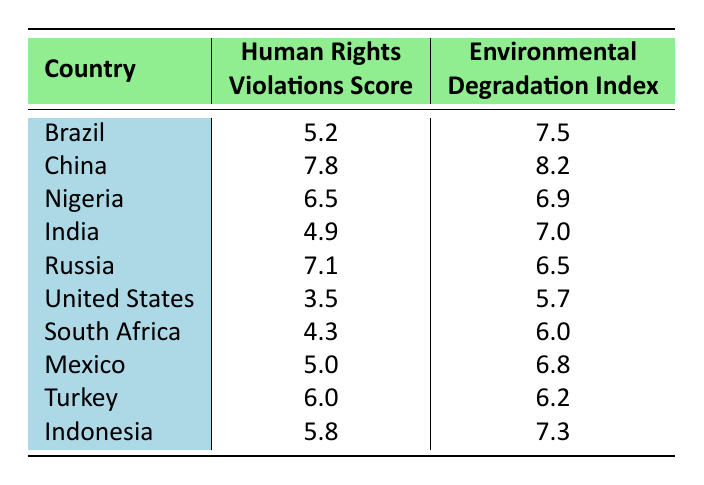What is the Human Rights Violations Score for Brazil? In the table, Brazil has a listed Human Rights Violations Score of 5.2.
Answer: 5.2 Which country has the highest Environmental Degradation Index? By looking at the Environmental Degradation Index values in the table, China has the highest score at 8.2.
Answer: China What is the Environmental Degradation Index for the United States? The table shows that the Environmental Degradation Index score for the United States is 5.7.
Answer: 5.7 What is the difference between the Human Rights Violations Score of China and India? The Human Rights Violations Score for China is 7.8 and for India is 4.9. The difference is 7.8 - 4.9 = 2.9.
Answer: 2.9 Is the Environmental Degradation Index for Nigeria greater than that of Russia? Nigeria has an Environmental Degradation Index of 6.9 while Russia's is 6.5. Since 6.9 is greater than 6.5, the statement is true.
Answer: Yes Which country has a lower Human Rights Violations Score: Turkey or Mexico? Turkey has a score of 6.0 and Mexico has a score of 5.0. Since 5.0 is lower than 6.0, Mexico has the lower score.
Answer: Mexico What is the average Human Rights Violations Score for all the countries listed? The sum of the scores is 5.2 + 7.8 + 6.5 + 4.9 + 7.1 + 3.5 + 4.3 + 5.0 + 6.0 + 5.8 = 56.1. There are 10 countries, so the average is 56.1 / 10 = 5.61.
Answer: 5.61 Is there any country with a Human Rights Violations Score of 3.0 or below? The lowest score in the table is for the United States at 3.5, which is above 3.0. Thus, there are no countries with a score of 3.0 or below.
Answer: No Which country has the lowest Environmental Degradation Index? From the values in the table, the United States has the lowest Environmental Degradation Index of 5.7.
Answer: United States 